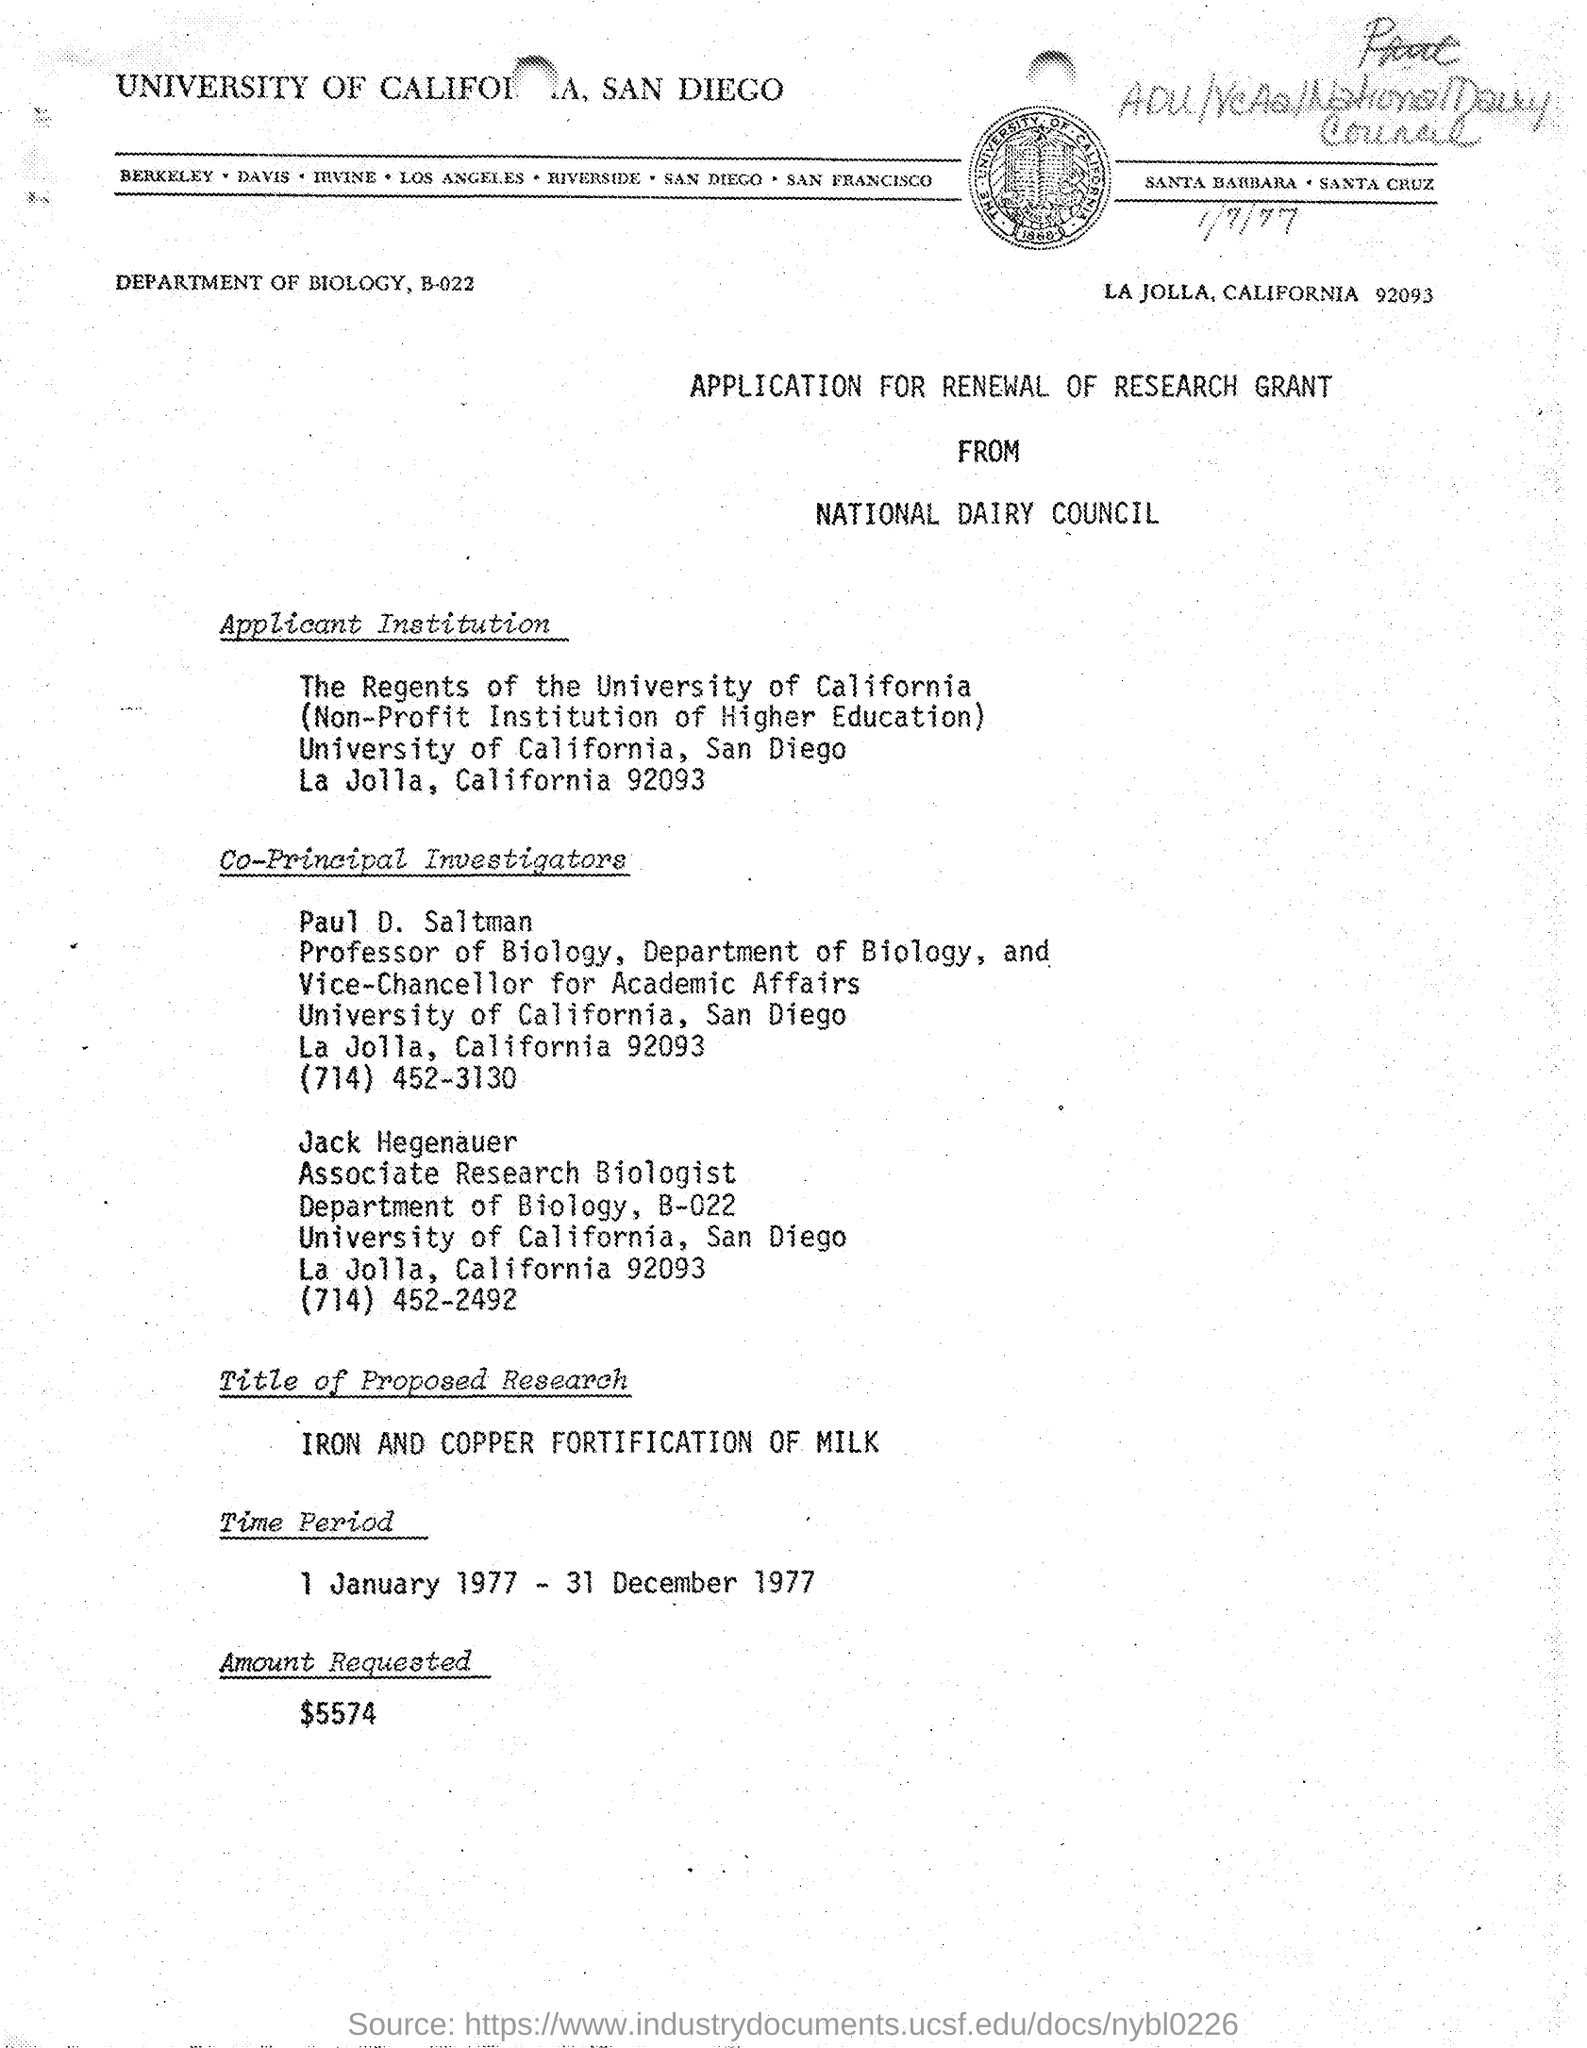What is the title of proposed project ?
Your answer should be compact. Iron and Copper fortification of milk. What is the amount requested as mentioned in the given application ?
Your answer should be compact. $5574. What is the name of the application ?
Give a very brief answer. Application for renewal of research grant. What is the name of the applicant institution as mentioned in the given application ?
Your answer should be compact. The Regents of the university of California. To which department paul d. saltman belongs to ?
Provide a short and direct response. Department of biology. What is the designation of jack hegenauer ?
Provide a short and direct response. Associate Research Biologist. To which university jack hegenauer belongs to ?
Ensure brevity in your answer.  University of california. 